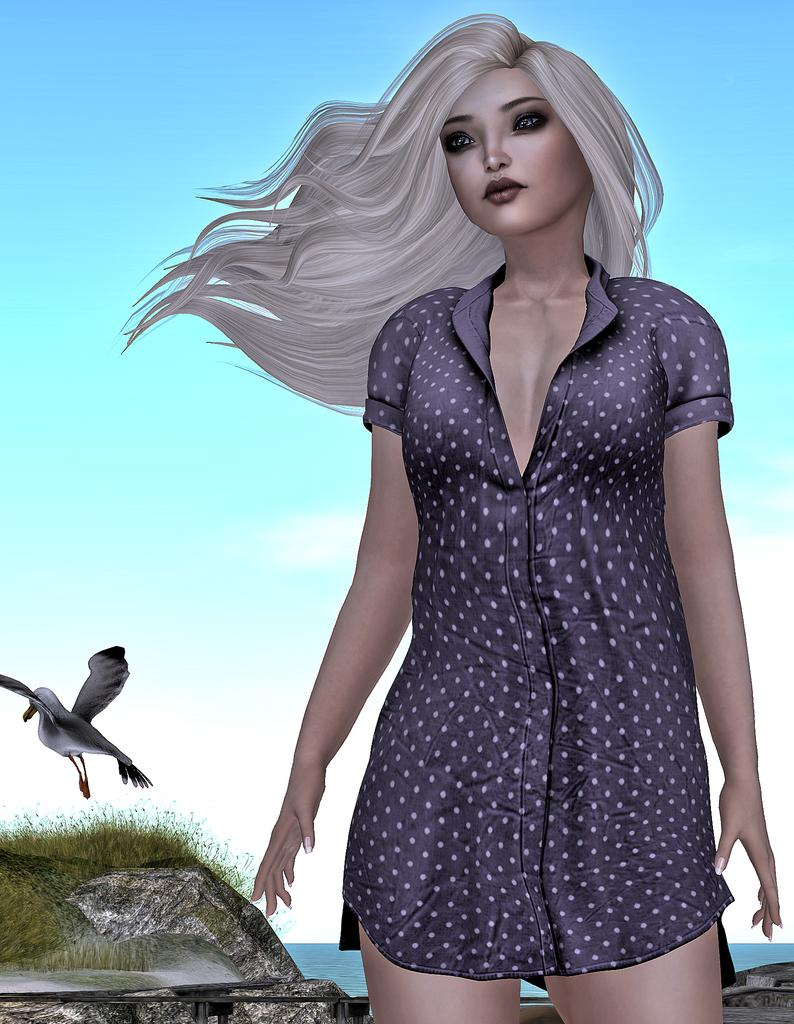Who is present in the image? There is a woman in the image. What type of natural environment is visible in the image? There is grass in the image. What animal can be seen in the image? There is a bird in the image. What body of water is present in the image? There is water in the image. What can be seen in the sky in the image? There are clouds in the image, and the sky is visible. What month is it in the image? The month is not mentioned or depicted in the image, so it cannot be determined. Can you see a snake in the image? No, there is no snake present in the image. 